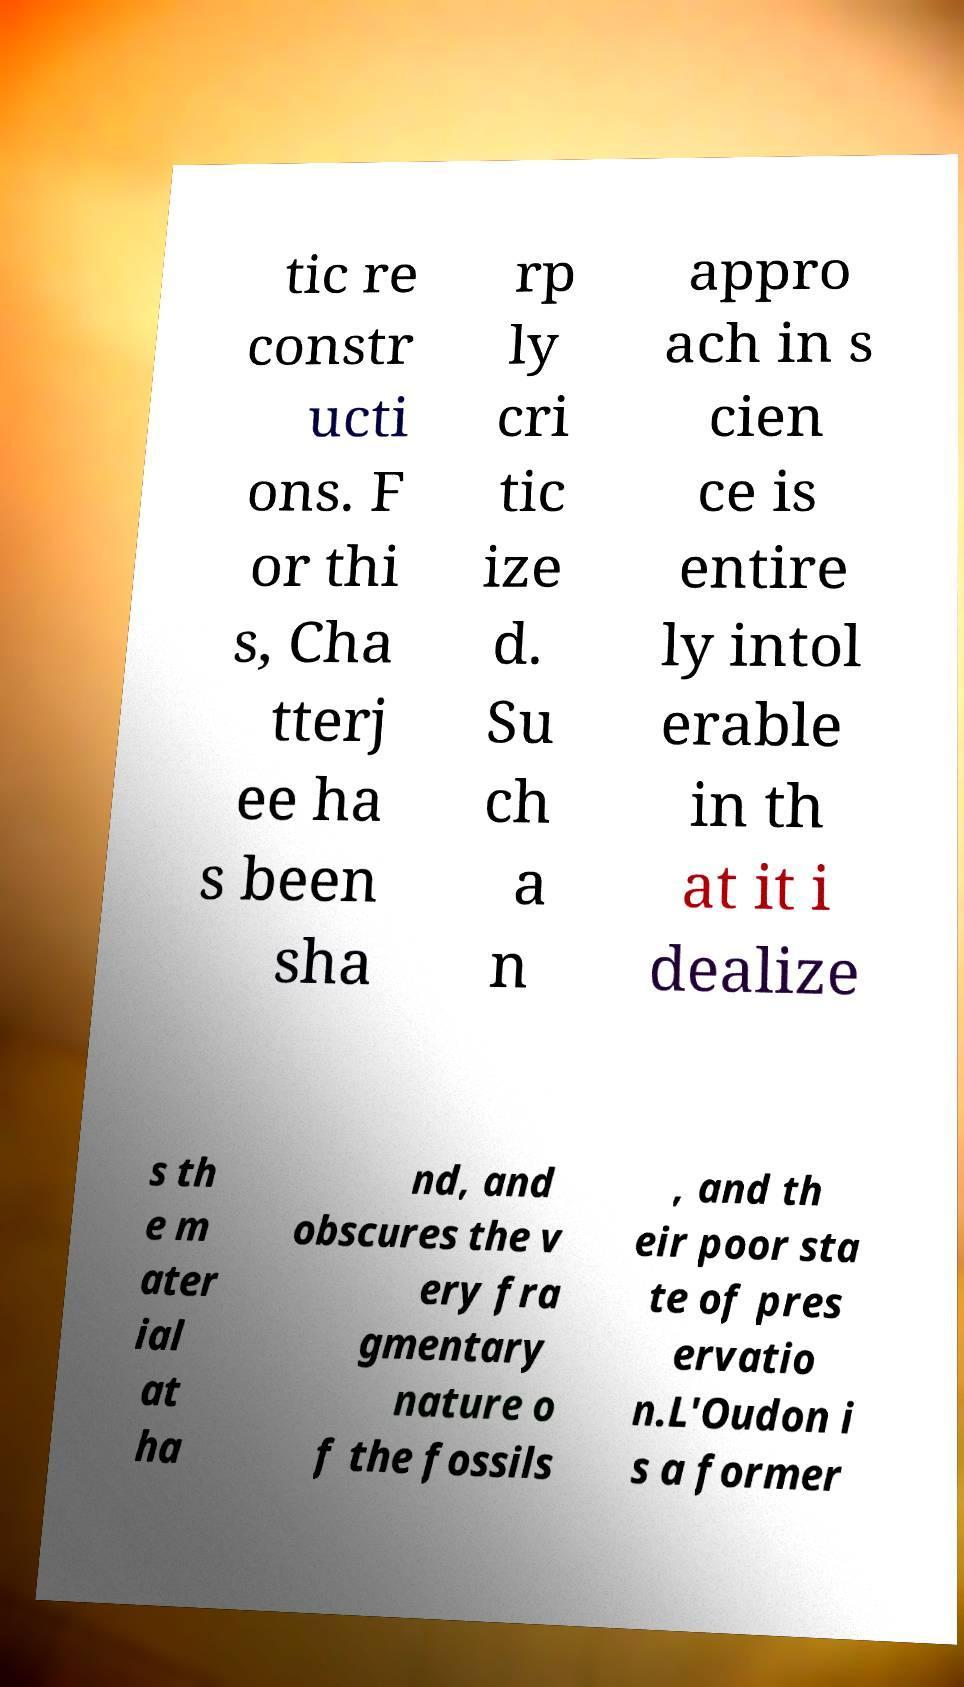Please read and relay the text visible in this image. What does it say? tic re constr ucti ons. F or thi s, Cha tterj ee ha s been sha rp ly cri tic ize d. Su ch a n appro ach in s cien ce is entire ly intol erable in th at it i dealize s th e m ater ial at ha nd, and obscures the v ery fra gmentary nature o f the fossils , and th eir poor sta te of pres ervatio n.L'Oudon i s a former 